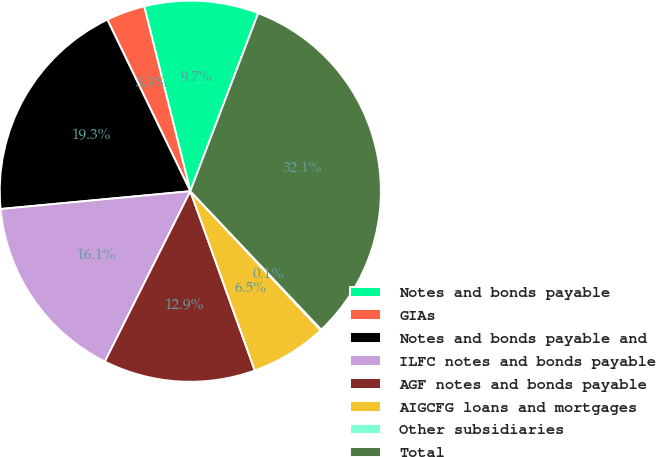Convert chart to OTSL. <chart><loc_0><loc_0><loc_500><loc_500><pie_chart><fcel>Notes and bonds payable<fcel>GIAs<fcel>Notes and bonds payable and<fcel>ILFC notes and bonds payable<fcel>AGF notes and bonds payable<fcel>AIGCFG loans and mortgages<fcel>Other subsidiaries<fcel>Total<nl><fcel>9.69%<fcel>3.28%<fcel>19.32%<fcel>16.11%<fcel>12.9%<fcel>6.49%<fcel>0.07%<fcel>32.15%<nl></chart> 